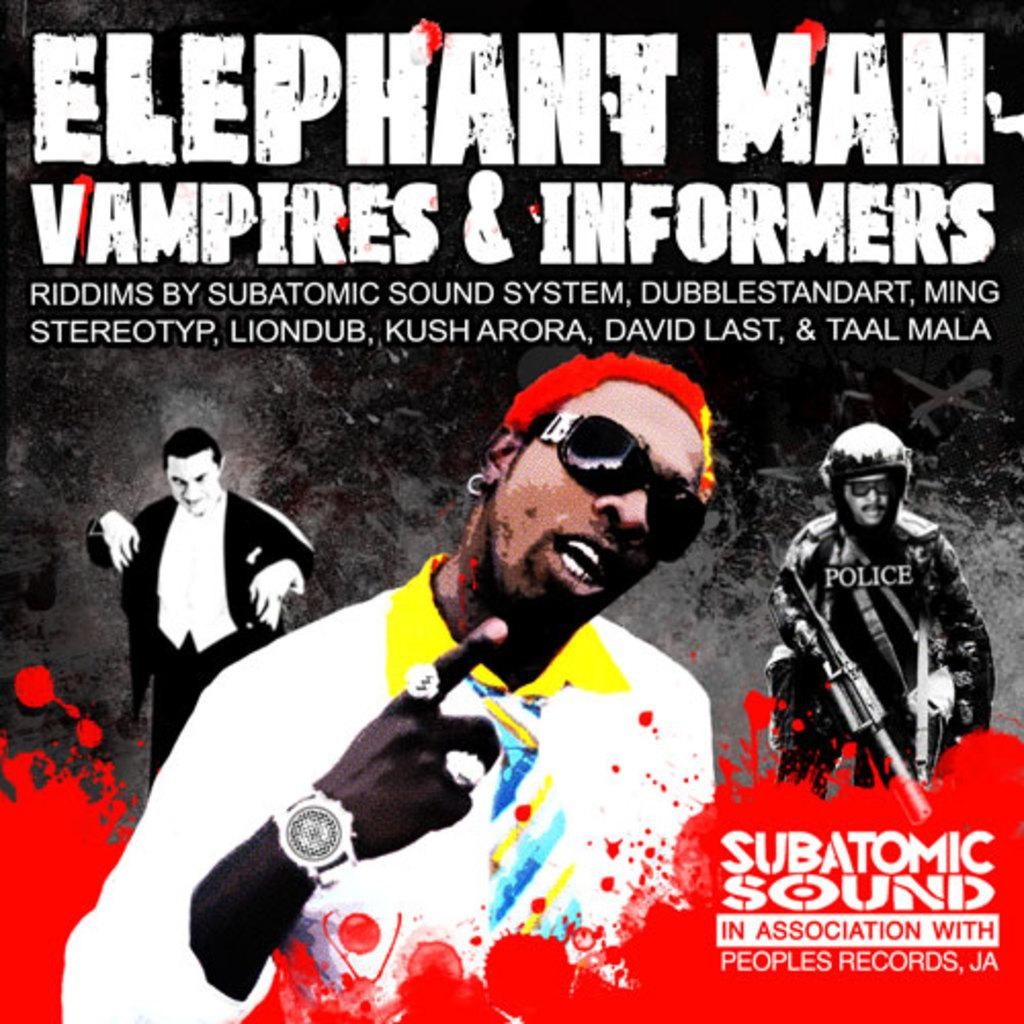Who or what can be seen in the image? There are persons in the image. What is written at the top of the image? There is text at the top of the image. What is written at the bottom of the image? There is text at the bottom of the image. What type of ear is visible on the person in the image? There is no ear visible on the person in the image. What is the competition that the persons are participating in within the image? There is no competition present in the image. 